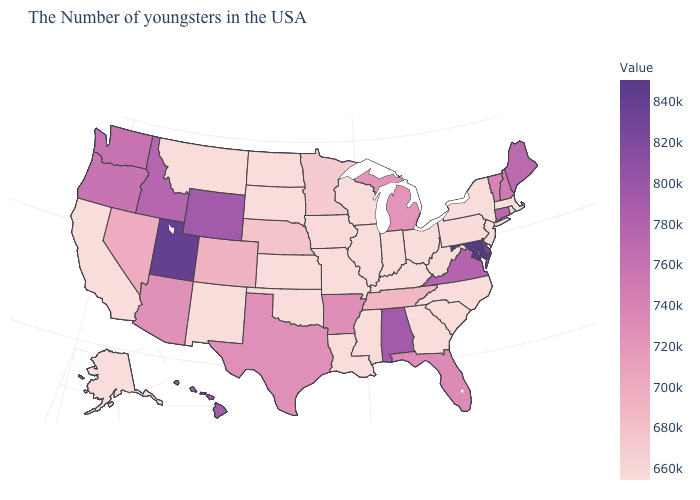Among the states that border Wyoming , which have the highest value?
Concise answer only. Utah. Does Michigan have a lower value than Mississippi?
Answer briefly. No. Among the states that border Tennessee , which have the lowest value?
Keep it brief. North Carolina, Georgia, Kentucky, Mississippi, Missouri. Among the states that border Delaware , which have the highest value?
Concise answer only. Maryland. 